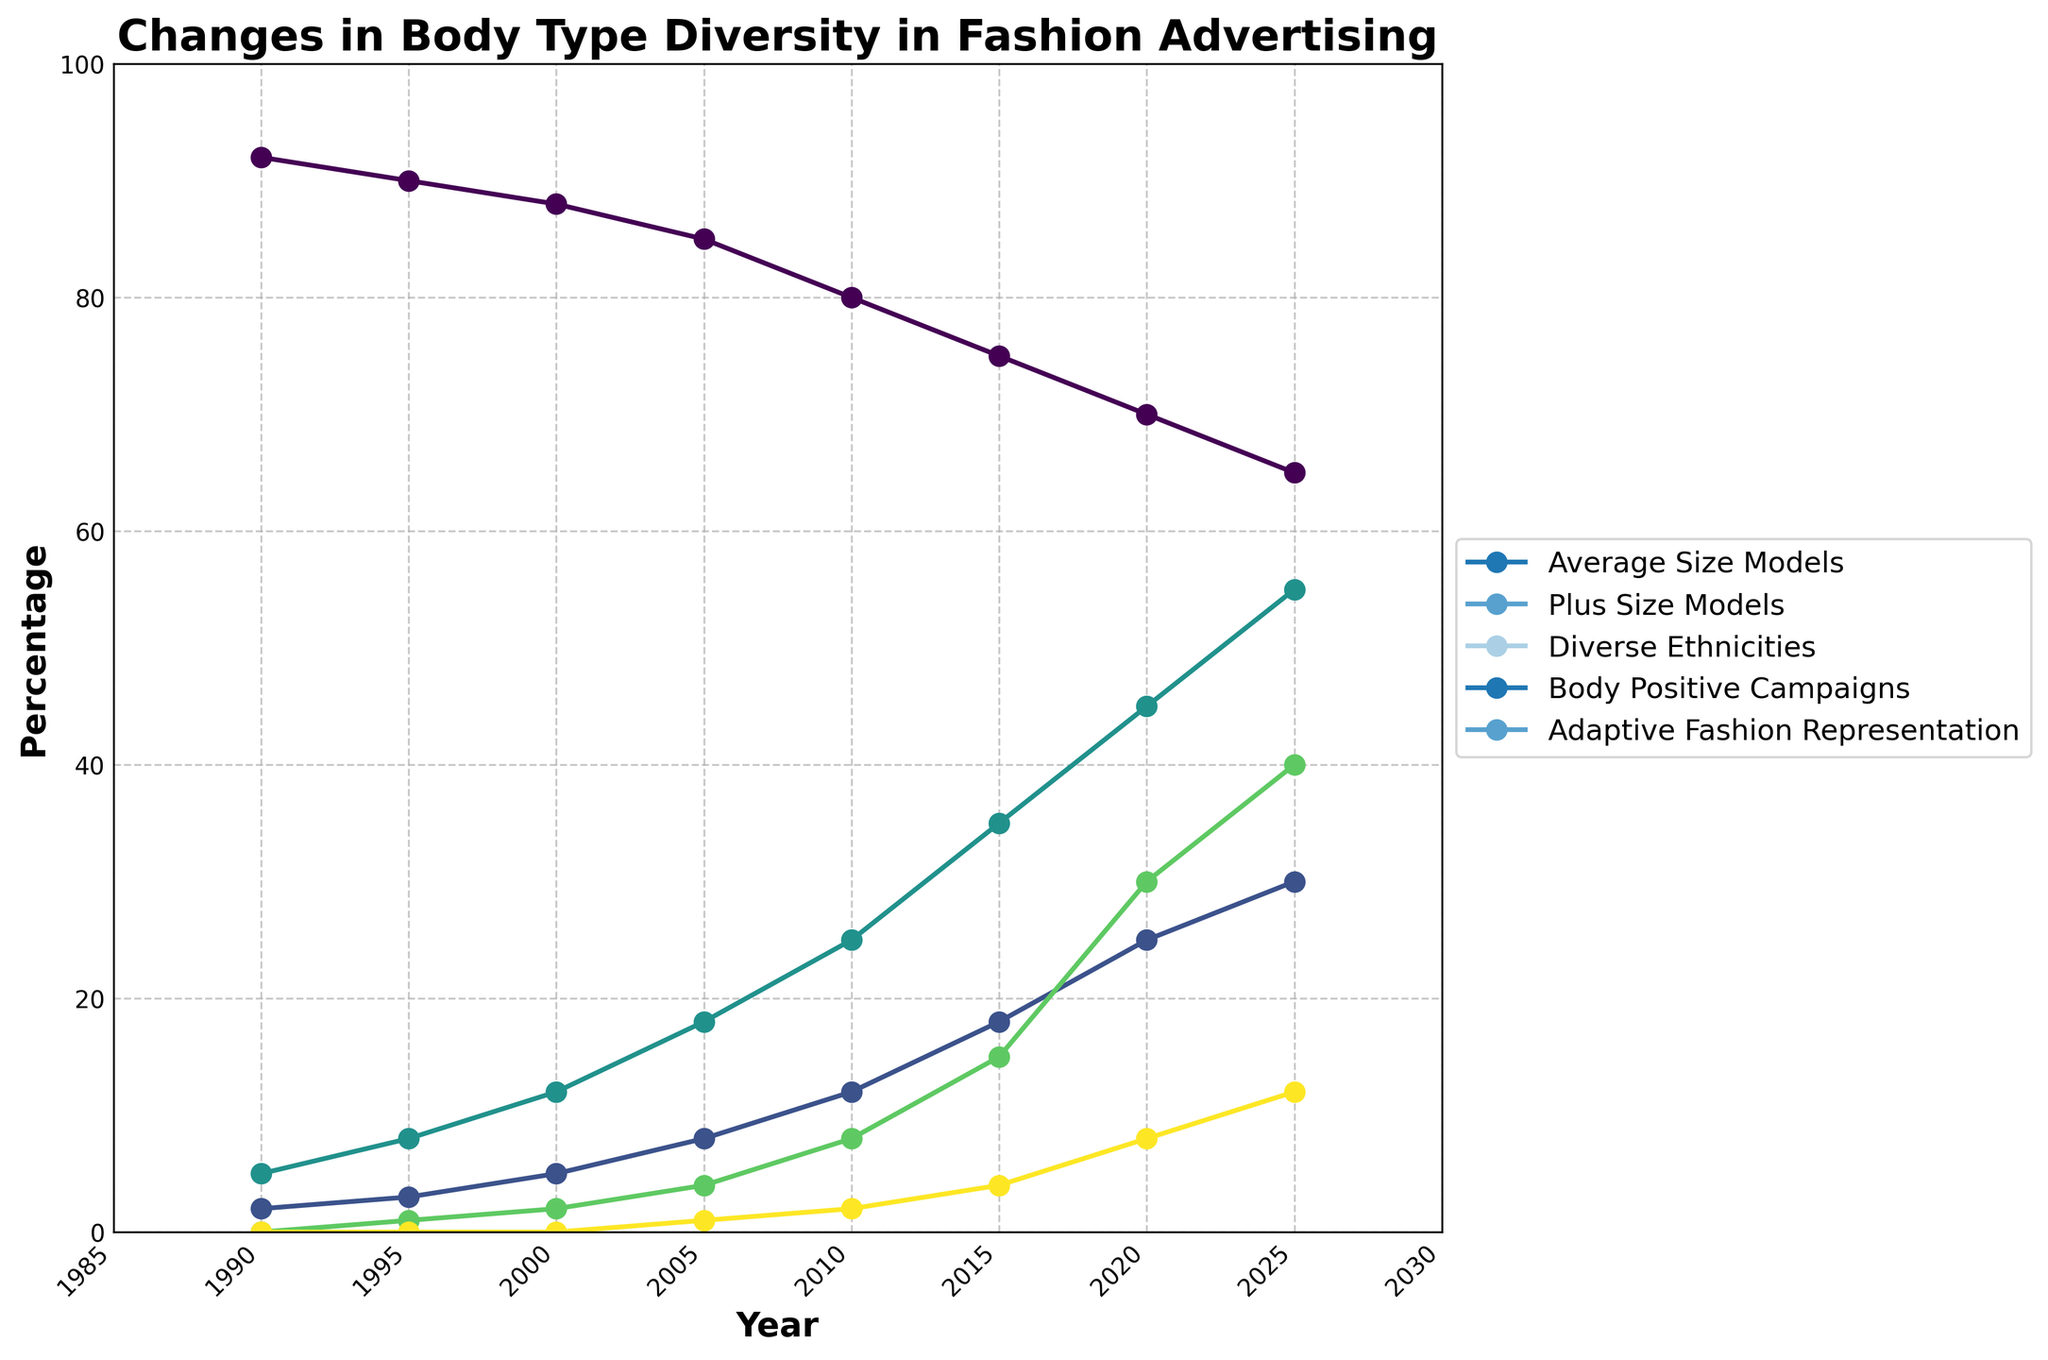Which year saw the highest percentage of Plus Size Models? To find the highest point on the line representing Plus Size Models in the plot, look for the highest peak in the trend line.
Answer: 2025 How many types of body type representations averaged at least 30% by 2025? Examine the percentage values for each line at the year 2025 and count how many of them are 30% or higher.
Answer: 2 (Plus Size Models and Diverse Ethnicities) Which category showed a constant increase in representation from 1990 to 2025? Follow each line from 1990 to 2025 and see which ones consistently move upwards without any declines over the years.
Answer: Body Positive Campaigns Calculate the average percentage of Diverse Ethnicities and Adaptive Fashion Representation in 2020. Add the percentage values of Diverse Ethnicities (45) and Adaptive Fashion Representation (8) for 2020, then divide by 2.
Answer: (45+8)/2 = 26.5 Compare the rate of increase between Plus Size Models and Body Positive Campaigns from 1990 to 2020. Which one grew faster? Examine the slope of the lines representing Plus Size Models and Body Positive Campaigns over the years from 1990 to 2020 and compare their steepness.
Answer: Body Positive Campaigns Which year had an equal representation percentage between Average Size Models and Diverse Ethnicities? Identify the year where the lines representing Average Size Models and Diverse Ethnicities intersect at an equal percentage value.
Answer: No year had equal representation percentages What is the total percentage change in Adaptive Fashion Representation from 1990 to 2025? Subtract the percentage of Adaptive Fashion Representation in 1990 (0) from the percentage in 2025 (12).
Answer: 12-0 = 12 Identify the year when Body Positive Campaigns first reached a double-digit value. Find the first point on the Body Positive Campaigns line that hits 10% or higher.
Answer: 2010 By how many percentage points did the representation of Plus Size Models increase from 2000 to 2020? Subtract the percentage of Plus Size Models in 2000 (5%) from the percentage in 2020 (25%).
Answer: 25-5 = 20 